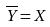<formula> <loc_0><loc_0><loc_500><loc_500>\overline { Y } = X</formula> 